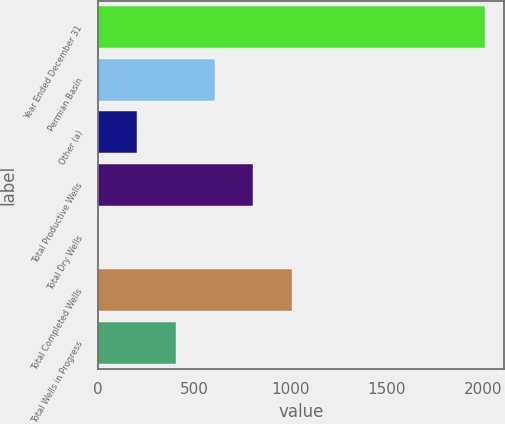Convert chart. <chart><loc_0><loc_0><loc_500><loc_500><bar_chart><fcel>Year Ended December 31<fcel>Permian Basin<fcel>Other (a)<fcel>Total Productive Wells<fcel>Total Dry Wells<fcel>Total Completed Wells<fcel>Total Wells in Progress<nl><fcel>2009<fcel>606.2<fcel>205.4<fcel>806.6<fcel>5<fcel>1007<fcel>405.8<nl></chart> 